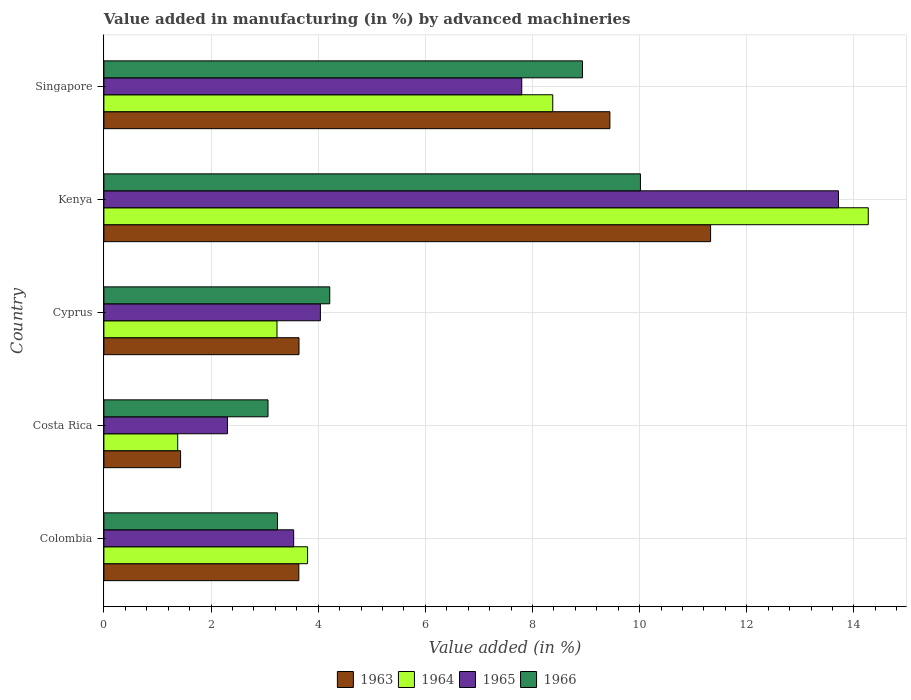How many groups of bars are there?
Keep it short and to the point. 5. Are the number of bars on each tick of the Y-axis equal?
Your answer should be very brief. Yes. What is the label of the 4th group of bars from the top?
Keep it short and to the point. Costa Rica. What is the percentage of value added in manufacturing by advanced machineries in 1964 in Colombia?
Offer a terse response. 3.8. Across all countries, what is the maximum percentage of value added in manufacturing by advanced machineries in 1964?
Your answer should be compact. 14.27. Across all countries, what is the minimum percentage of value added in manufacturing by advanced machineries in 1963?
Your answer should be compact. 1.43. In which country was the percentage of value added in manufacturing by advanced machineries in 1966 maximum?
Offer a terse response. Kenya. In which country was the percentage of value added in manufacturing by advanced machineries in 1966 minimum?
Your answer should be very brief. Costa Rica. What is the total percentage of value added in manufacturing by advanced machineries in 1965 in the graph?
Make the answer very short. 31.4. What is the difference between the percentage of value added in manufacturing by advanced machineries in 1966 in Colombia and that in Singapore?
Ensure brevity in your answer.  -5.69. What is the difference between the percentage of value added in manufacturing by advanced machineries in 1963 in Colombia and the percentage of value added in manufacturing by advanced machineries in 1966 in Kenya?
Keep it short and to the point. -6.38. What is the average percentage of value added in manufacturing by advanced machineries in 1964 per country?
Provide a short and direct response. 6.21. What is the difference between the percentage of value added in manufacturing by advanced machineries in 1965 and percentage of value added in manufacturing by advanced machineries in 1963 in Colombia?
Ensure brevity in your answer.  -0.1. What is the ratio of the percentage of value added in manufacturing by advanced machineries in 1966 in Cyprus to that in Kenya?
Your answer should be compact. 0.42. Is the difference between the percentage of value added in manufacturing by advanced machineries in 1965 in Costa Rica and Kenya greater than the difference between the percentage of value added in manufacturing by advanced machineries in 1963 in Costa Rica and Kenya?
Your answer should be very brief. No. What is the difference between the highest and the second highest percentage of value added in manufacturing by advanced machineries in 1963?
Your answer should be compact. 1.88. What is the difference between the highest and the lowest percentage of value added in manufacturing by advanced machineries in 1965?
Your answer should be compact. 11.4. In how many countries, is the percentage of value added in manufacturing by advanced machineries in 1963 greater than the average percentage of value added in manufacturing by advanced machineries in 1963 taken over all countries?
Provide a succinct answer. 2. Is the sum of the percentage of value added in manufacturing by advanced machineries in 1963 in Colombia and Cyprus greater than the maximum percentage of value added in manufacturing by advanced machineries in 1964 across all countries?
Provide a short and direct response. No. Is it the case that in every country, the sum of the percentage of value added in manufacturing by advanced machineries in 1965 and percentage of value added in manufacturing by advanced machineries in 1966 is greater than the sum of percentage of value added in manufacturing by advanced machineries in 1963 and percentage of value added in manufacturing by advanced machineries in 1964?
Give a very brief answer. No. What does the 3rd bar from the top in Colombia represents?
Your answer should be very brief. 1964. What does the 3rd bar from the bottom in Colombia represents?
Keep it short and to the point. 1965. How many countries are there in the graph?
Offer a terse response. 5. Does the graph contain any zero values?
Your answer should be compact. No. Where does the legend appear in the graph?
Offer a very short reply. Bottom center. How many legend labels are there?
Offer a terse response. 4. What is the title of the graph?
Your response must be concise. Value added in manufacturing (in %) by advanced machineries. What is the label or title of the X-axis?
Offer a very short reply. Value added (in %). What is the label or title of the Y-axis?
Keep it short and to the point. Country. What is the Value added (in %) of 1963 in Colombia?
Offer a very short reply. 3.64. What is the Value added (in %) in 1964 in Colombia?
Provide a short and direct response. 3.8. What is the Value added (in %) in 1965 in Colombia?
Offer a very short reply. 3.54. What is the Value added (in %) of 1966 in Colombia?
Your response must be concise. 3.24. What is the Value added (in %) of 1963 in Costa Rica?
Offer a very short reply. 1.43. What is the Value added (in %) in 1964 in Costa Rica?
Keep it short and to the point. 1.38. What is the Value added (in %) in 1965 in Costa Rica?
Offer a terse response. 2.31. What is the Value added (in %) of 1966 in Costa Rica?
Your answer should be very brief. 3.06. What is the Value added (in %) of 1963 in Cyprus?
Make the answer very short. 3.64. What is the Value added (in %) in 1964 in Cyprus?
Offer a terse response. 3.23. What is the Value added (in %) of 1965 in Cyprus?
Your answer should be very brief. 4.04. What is the Value added (in %) in 1966 in Cyprus?
Ensure brevity in your answer.  4.22. What is the Value added (in %) of 1963 in Kenya?
Your answer should be very brief. 11.32. What is the Value added (in %) in 1964 in Kenya?
Ensure brevity in your answer.  14.27. What is the Value added (in %) of 1965 in Kenya?
Provide a short and direct response. 13.71. What is the Value added (in %) in 1966 in Kenya?
Make the answer very short. 10.01. What is the Value added (in %) in 1963 in Singapore?
Ensure brevity in your answer.  9.44. What is the Value added (in %) in 1964 in Singapore?
Give a very brief answer. 8.38. What is the Value added (in %) in 1965 in Singapore?
Your answer should be very brief. 7.8. What is the Value added (in %) in 1966 in Singapore?
Keep it short and to the point. 8.93. Across all countries, what is the maximum Value added (in %) of 1963?
Your answer should be compact. 11.32. Across all countries, what is the maximum Value added (in %) in 1964?
Provide a short and direct response. 14.27. Across all countries, what is the maximum Value added (in %) in 1965?
Provide a succinct answer. 13.71. Across all countries, what is the maximum Value added (in %) of 1966?
Offer a terse response. 10.01. Across all countries, what is the minimum Value added (in %) of 1963?
Provide a short and direct response. 1.43. Across all countries, what is the minimum Value added (in %) in 1964?
Your response must be concise. 1.38. Across all countries, what is the minimum Value added (in %) in 1965?
Provide a succinct answer. 2.31. Across all countries, what is the minimum Value added (in %) in 1966?
Provide a short and direct response. 3.06. What is the total Value added (in %) of 1963 in the graph?
Keep it short and to the point. 29.48. What is the total Value added (in %) of 1964 in the graph?
Offer a very short reply. 31.05. What is the total Value added (in %) in 1965 in the graph?
Ensure brevity in your answer.  31.4. What is the total Value added (in %) in 1966 in the graph?
Ensure brevity in your answer.  29.47. What is the difference between the Value added (in %) of 1963 in Colombia and that in Costa Rica?
Ensure brevity in your answer.  2.21. What is the difference between the Value added (in %) in 1964 in Colombia and that in Costa Rica?
Give a very brief answer. 2.42. What is the difference between the Value added (in %) of 1965 in Colombia and that in Costa Rica?
Give a very brief answer. 1.24. What is the difference between the Value added (in %) in 1966 in Colombia and that in Costa Rica?
Your answer should be compact. 0.18. What is the difference between the Value added (in %) of 1963 in Colombia and that in Cyprus?
Ensure brevity in your answer.  -0. What is the difference between the Value added (in %) of 1964 in Colombia and that in Cyprus?
Offer a terse response. 0.57. What is the difference between the Value added (in %) of 1965 in Colombia and that in Cyprus?
Provide a succinct answer. -0.5. What is the difference between the Value added (in %) of 1966 in Colombia and that in Cyprus?
Give a very brief answer. -0.97. What is the difference between the Value added (in %) in 1963 in Colombia and that in Kenya?
Ensure brevity in your answer.  -7.69. What is the difference between the Value added (in %) in 1964 in Colombia and that in Kenya?
Make the answer very short. -10.47. What is the difference between the Value added (in %) in 1965 in Colombia and that in Kenya?
Your answer should be compact. -10.17. What is the difference between the Value added (in %) in 1966 in Colombia and that in Kenya?
Provide a succinct answer. -6.77. What is the difference between the Value added (in %) in 1963 in Colombia and that in Singapore?
Give a very brief answer. -5.81. What is the difference between the Value added (in %) of 1964 in Colombia and that in Singapore?
Offer a terse response. -4.58. What is the difference between the Value added (in %) of 1965 in Colombia and that in Singapore?
Offer a terse response. -4.26. What is the difference between the Value added (in %) of 1966 in Colombia and that in Singapore?
Offer a terse response. -5.69. What is the difference between the Value added (in %) in 1963 in Costa Rica and that in Cyprus?
Give a very brief answer. -2.21. What is the difference between the Value added (in %) in 1964 in Costa Rica and that in Cyprus?
Provide a succinct answer. -1.85. What is the difference between the Value added (in %) in 1965 in Costa Rica and that in Cyprus?
Provide a short and direct response. -1.73. What is the difference between the Value added (in %) of 1966 in Costa Rica and that in Cyprus?
Provide a succinct answer. -1.15. What is the difference between the Value added (in %) in 1963 in Costa Rica and that in Kenya?
Give a very brief answer. -9.89. What is the difference between the Value added (in %) in 1964 in Costa Rica and that in Kenya?
Provide a succinct answer. -12.89. What is the difference between the Value added (in %) in 1965 in Costa Rica and that in Kenya?
Make the answer very short. -11.4. What is the difference between the Value added (in %) of 1966 in Costa Rica and that in Kenya?
Offer a terse response. -6.95. What is the difference between the Value added (in %) in 1963 in Costa Rica and that in Singapore?
Your answer should be compact. -8.01. What is the difference between the Value added (in %) in 1964 in Costa Rica and that in Singapore?
Offer a terse response. -7. What is the difference between the Value added (in %) in 1965 in Costa Rica and that in Singapore?
Offer a terse response. -5.49. What is the difference between the Value added (in %) in 1966 in Costa Rica and that in Singapore?
Your answer should be very brief. -5.87. What is the difference between the Value added (in %) in 1963 in Cyprus and that in Kenya?
Ensure brevity in your answer.  -7.68. What is the difference between the Value added (in %) of 1964 in Cyprus and that in Kenya?
Keep it short and to the point. -11.04. What is the difference between the Value added (in %) in 1965 in Cyprus and that in Kenya?
Offer a very short reply. -9.67. What is the difference between the Value added (in %) in 1966 in Cyprus and that in Kenya?
Make the answer very short. -5.8. What is the difference between the Value added (in %) in 1963 in Cyprus and that in Singapore?
Make the answer very short. -5.8. What is the difference between the Value added (in %) of 1964 in Cyprus and that in Singapore?
Give a very brief answer. -5.15. What is the difference between the Value added (in %) in 1965 in Cyprus and that in Singapore?
Give a very brief answer. -3.76. What is the difference between the Value added (in %) of 1966 in Cyprus and that in Singapore?
Keep it short and to the point. -4.72. What is the difference between the Value added (in %) of 1963 in Kenya and that in Singapore?
Give a very brief answer. 1.88. What is the difference between the Value added (in %) of 1964 in Kenya and that in Singapore?
Offer a very short reply. 5.89. What is the difference between the Value added (in %) in 1965 in Kenya and that in Singapore?
Your answer should be compact. 5.91. What is the difference between the Value added (in %) in 1966 in Kenya and that in Singapore?
Your answer should be compact. 1.08. What is the difference between the Value added (in %) in 1963 in Colombia and the Value added (in %) in 1964 in Costa Rica?
Your answer should be compact. 2.26. What is the difference between the Value added (in %) of 1963 in Colombia and the Value added (in %) of 1965 in Costa Rica?
Give a very brief answer. 1.33. What is the difference between the Value added (in %) in 1963 in Colombia and the Value added (in %) in 1966 in Costa Rica?
Your response must be concise. 0.57. What is the difference between the Value added (in %) in 1964 in Colombia and the Value added (in %) in 1965 in Costa Rica?
Offer a terse response. 1.49. What is the difference between the Value added (in %) of 1964 in Colombia and the Value added (in %) of 1966 in Costa Rica?
Your response must be concise. 0.74. What is the difference between the Value added (in %) in 1965 in Colombia and the Value added (in %) in 1966 in Costa Rica?
Your answer should be compact. 0.48. What is the difference between the Value added (in %) in 1963 in Colombia and the Value added (in %) in 1964 in Cyprus?
Your answer should be very brief. 0.41. What is the difference between the Value added (in %) in 1963 in Colombia and the Value added (in %) in 1965 in Cyprus?
Your answer should be very brief. -0.4. What is the difference between the Value added (in %) of 1963 in Colombia and the Value added (in %) of 1966 in Cyprus?
Offer a very short reply. -0.58. What is the difference between the Value added (in %) of 1964 in Colombia and the Value added (in %) of 1965 in Cyprus?
Ensure brevity in your answer.  -0.24. What is the difference between the Value added (in %) of 1964 in Colombia and the Value added (in %) of 1966 in Cyprus?
Offer a very short reply. -0.41. What is the difference between the Value added (in %) of 1965 in Colombia and the Value added (in %) of 1966 in Cyprus?
Ensure brevity in your answer.  -0.67. What is the difference between the Value added (in %) of 1963 in Colombia and the Value added (in %) of 1964 in Kenya?
Offer a very short reply. -10.63. What is the difference between the Value added (in %) of 1963 in Colombia and the Value added (in %) of 1965 in Kenya?
Your answer should be compact. -10.07. What is the difference between the Value added (in %) in 1963 in Colombia and the Value added (in %) in 1966 in Kenya?
Offer a very short reply. -6.38. What is the difference between the Value added (in %) in 1964 in Colombia and the Value added (in %) in 1965 in Kenya?
Offer a terse response. -9.91. What is the difference between the Value added (in %) of 1964 in Colombia and the Value added (in %) of 1966 in Kenya?
Your answer should be compact. -6.21. What is the difference between the Value added (in %) of 1965 in Colombia and the Value added (in %) of 1966 in Kenya?
Make the answer very short. -6.47. What is the difference between the Value added (in %) of 1963 in Colombia and the Value added (in %) of 1964 in Singapore?
Your answer should be very brief. -4.74. What is the difference between the Value added (in %) in 1963 in Colombia and the Value added (in %) in 1965 in Singapore?
Give a very brief answer. -4.16. What is the difference between the Value added (in %) of 1963 in Colombia and the Value added (in %) of 1966 in Singapore?
Your answer should be compact. -5.29. What is the difference between the Value added (in %) of 1964 in Colombia and the Value added (in %) of 1965 in Singapore?
Keep it short and to the point. -4. What is the difference between the Value added (in %) of 1964 in Colombia and the Value added (in %) of 1966 in Singapore?
Make the answer very short. -5.13. What is the difference between the Value added (in %) of 1965 in Colombia and the Value added (in %) of 1966 in Singapore?
Give a very brief answer. -5.39. What is the difference between the Value added (in %) of 1963 in Costa Rica and the Value added (in %) of 1964 in Cyprus?
Offer a very short reply. -1.8. What is the difference between the Value added (in %) in 1963 in Costa Rica and the Value added (in %) in 1965 in Cyprus?
Your response must be concise. -2.61. What is the difference between the Value added (in %) of 1963 in Costa Rica and the Value added (in %) of 1966 in Cyprus?
Give a very brief answer. -2.78. What is the difference between the Value added (in %) in 1964 in Costa Rica and the Value added (in %) in 1965 in Cyprus?
Offer a terse response. -2.66. What is the difference between the Value added (in %) in 1964 in Costa Rica and the Value added (in %) in 1966 in Cyprus?
Make the answer very short. -2.84. What is the difference between the Value added (in %) in 1965 in Costa Rica and the Value added (in %) in 1966 in Cyprus?
Provide a short and direct response. -1.91. What is the difference between the Value added (in %) of 1963 in Costa Rica and the Value added (in %) of 1964 in Kenya?
Offer a terse response. -12.84. What is the difference between the Value added (in %) in 1963 in Costa Rica and the Value added (in %) in 1965 in Kenya?
Give a very brief answer. -12.28. What is the difference between the Value added (in %) in 1963 in Costa Rica and the Value added (in %) in 1966 in Kenya?
Your answer should be compact. -8.58. What is the difference between the Value added (in %) in 1964 in Costa Rica and the Value added (in %) in 1965 in Kenya?
Your answer should be compact. -12.33. What is the difference between the Value added (in %) of 1964 in Costa Rica and the Value added (in %) of 1966 in Kenya?
Keep it short and to the point. -8.64. What is the difference between the Value added (in %) in 1965 in Costa Rica and the Value added (in %) in 1966 in Kenya?
Provide a succinct answer. -7.71. What is the difference between the Value added (in %) of 1963 in Costa Rica and the Value added (in %) of 1964 in Singapore?
Give a very brief answer. -6.95. What is the difference between the Value added (in %) of 1963 in Costa Rica and the Value added (in %) of 1965 in Singapore?
Make the answer very short. -6.37. What is the difference between the Value added (in %) in 1963 in Costa Rica and the Value added (in %) in 1966 in Singapore?
Provide a succinct answer. -7.5. What is the difference between the Value added (in %) in 1964 in Costa Rica and the Value added (in %) in 1965 in Singapore?
Provide a succinct answer. -6.42. What is the difference between the Value added (in %) in 1964 in Costa Rica and the Value added (in %) in 1966 in Singapore?
Provide a succinct answer. -7.55. What is the difference between the Value added (in %) in 1965 in Costa Rica and the Value added (in %) in 1966 in Singapore?
Give a very brief answer. -6.63. What is the difference between the Value added (in %) in 1963 in Cyprus and the Value added (in %) in 1964 in Kenya?
Keep it short and to the point. -10.63. What is the difference between the Value added (in %) in 1963 in Cyprus and the Value added (in %) in 1965 in Kenya?
Provide a succinct answer. -10.07. What is the difference between the Value added (in %) of 1963 in Cyprus and the Value added (in %) of 1966 in Kenya?
Provide a succinct answer. -6.37. What is the difference between the Value added (in %) in 1964 in Cyprus and the Value added (in %) in 1965 in Kenya?
Give a very brief answer. -10.48. What is the difference between the Value added (in %) of 1964 in Cyprus and the Value added (in %) of 1966 in Kenya?
Offer a very short reply. -6.78. What is the difference between the Value added (in %) of 1965 in Cyprus and the Value added (in %) of 1966 in Kenya?
Ensure brevity in your answer.  -5.97. What is the difference between the Value added (in %) in 1963 in Cyprus and the Value added (in %) in 1964 in Singapore?
Provide a succinct answer. -4.74. What is the difference between the Value added (in %) of 1963 in Cyprus and the Value added (in %) of 1965 in Singapore?
Give a very brief answer. -4.16. What is the difference between the Value added (in %) in 1963 in Cyprus and the Value added (in %) in 1966 in Singapore?
Your answer should be very brief. -5.29. What is the difference between the Value added (in %) of 1964 in Cyprus and the Value added (in %) of 1965 in Singapore?
Provide a succinct answer. -4.57. What is the difference between the Value added (in %) in 1964 in Cyprus and the Value added (in %) in 1966 in Singapore?
Your response must be concise. -5.7. What is the difference between the Value added (in %) of 1965 in Cyprus and the Value added (in %) of 1966 in Singapore?
Your answer should be compact. -4.89. What is the difference between the Value added (in %) in 1963 in Kenya and the Value added (in %) in 1964 in Singapore?
Offer a very short reply. 2.95. What is the difference between the Value added (in %) in 1963 in Kenya and the Value added (in %) in 1965 in Singapore?
Your answer should be compact. 3.52. What is the difference between the Value added (in %) of 1963 in Kenya and the Value added (in %) of 1966 in Singapore?
Give a very brief answer. 2.39. What is the difference between the Value added (in %) of 1964 in Kenya and the Value added (in %) of 1965 in Singapore?
Give a very brief answer. 6.47. What is the difference between the Value added (in %) in 1964 in Kenya and the Value added (in %) in 1966 in Singapore?
Your answer should be compact. 5.33. What is the difference between the Value added (in %) in 1965 in Kenya and the Value added (in %) in 1966 in Singapore?
Provide a short and direct response. 4.78. What is the average Value added (in %) in 1963 per country?
Your answer should be very brief. 5.9. What is the average Value added (in %) in 1964 per country?
Your answer should be compact. 6.21. What is the average Value added (in %) in 1965 per country?
Offer a very short reply. 6.28. What is the average Value added (in %) of 1966 per country?
Your answer should be very brief. 5.89. What is the difference between the Value added (in %) in 1963 and Value added (in %) in 1964 in Colombia?
Make the answer very short. -0.16. What is the difference between the Value added (in %) of 1963 and Value added (in %) of 1965 in Colombia?
Offer a very short reply. 0.1. What is the difference between the Value added (in %) in 1963 and Value added (in %) in 1966 in Colombia?
Keep it short and to the point. 0.4. What is the difference between the Value added (in %) in 1964 and Value added (in %) in 1965 in Colombia?
Your response must be concise. 0.26. What is the difference between the Value added (in %) of 1964 and Value added (in %) of 1966 in Colombia?
Give a very brief answer. 0.56. What is the difference between the Value added (in %) in 1965 and Value added (in %) in 1966 in Colombia?
Provide a succinct answer. 0.3. What is the difference between the Value added (in %) in 1963 and Value added (in %) in 1964 in Costa Rica?
Your answer should be compact. 0.05. What is the difference between the Value added (in %) of 1963 and Value added (in %) of 1965 in Costa Rica?
Give a very brief answer. -0.88. What is the difference between the Value added (in %) in 1963 and Value added (in %) in 1966 in Costa Rica?
Offer a terse response. -1.63. What is the difference between the Value added (in %) of 1964 and Value added (in %) of 1965 in Costa Rica?
Your answer should be very brief. -0.93. What is the difference between the Value added (in %) of 1964 and Value added (in %) of 1966 in Costa Rica?
Your answer should be very brief. -1.69. What is the difference between the Value added (in %) in 1965 and Value added (in %) in 1966 in Costa Rica?
Make the answer very short. -0.76. What is the difference between the Value added (in %) in 1963 and Value added (in %) in 1964 in Cyprus?
Your answer should be very brief. 0.41. What is the difference between the Value added (in %) in 1963 and Value added (in %) in 1965 in Cyprus?
Ensure brevity in your answer.  -0.4. What is the difference between the Value added (in %) of 1963 and Value added (in %) of 1966 in Cyprus?
Keep it short and to the point. -0.57. What is the difference between the Value added (in %) of 1964 and Value added (in %) of 1965 in Cyprus?
Keep it short and to the point. -0.81. What is the difference between the Value added (in %) in 1964 and Value added (in %) in 1966 in Cyprus?
Offer a terse response. -0.98. What is the difference between the Value added (in %) of 1965 and Value added (in %) of 1966 in Cyprus?
Provide a short and direct response. -0.17. What is the difference between the Value added (in %) of 1963 and Value added (in %) of 1964 in Kenya?
Keep it short and to the point. -2.94. What is the difference between the Value added (in %) of 1963 and Value added (in %) of 1965 in Kenya?
Make the answer very short. -2.39. What is the difference between the Value added (in %) of 1963 and Value added (in %) of 1966 in Kenya?
Offer a very short reply. 1.31. What is the difference between the Value added (in %) in 1964 and Value added (in %) in 1965 in Kenya?
Keep it short and to the point. 0.56. What is the difference between the Value added (in %) in 1964 and Value added (in %) in 1966 in Kenya?
Offer a terse response. 4.25. What is the difference between the Value added (in %) of 1965 and Value added (in %) of 1966 in Kenya?
Give a very brief answer. 3.7. What is the difference between the Value added (in %) of 1963 and Value added (in %) of 1964 in Singapore?
Keep it short and to the point. 1.07. What is the difference between the Value added (in %) of 1963 and Value added (in %) of 1965 in Singapore?
Give a very brief answer. 1.64. What is the difference between the Value added (in %) of 1963 and Value added (in %) of 1966 in Singapore?
Give a very brief answer. 0.51. What is the difference between the Value added (in %) of 1964 and Value added (in %) of 1965 in Singapore?
Offer a very short reply. 0.58. What is the difference between the Value added (in %) of 1964 and Value added (in %) of 1966 in Singapore?
Your answer should be compact. -0.55. What is the difference between the Value added (in %) in 1965 and Value added (in %) in 1966 in Singapore?
Your answer should be very brief. -1.13. What is the ratio of the Value added (in %) in 1963 in Colombia to that in Costa Rica?
Offer a terse response. 2.54. What is the ratio of the Value added (in %) of 1964 in Colombia to that in Costa Rica?
Provide a short and direct response. 2.76. What is the ratio of the Value added (in %) in 1965 in Colombia to that in Costa Rica?
Ensure brevity in your answer.  1.54. What is the ratio of the Value added (in %) of 1966 in Colombia to that in Costa Rica?
Offer a terse response. 1.06. What is the ratio of the Value added (in %) in 1963 in Colombia to that in Cyprus?
Provide a succinct answer. 1. What is the ratio of the Value added (in %) of 1964 in Colombia to that in Cyprus?
Ensure brevity in your answer.  1.18. What is the ratio of the Value added (in %) of 1965 in Colombia to that in Cyprus?
Keep it short and to the point. 0.88. What is the ratio of the Value added (in %) in 1966 in Colombia to that in Cyprus?
Your answer should be very brief. 0.77. What is the ratio of the Value added (in %) in 1963 in Colombia to that in Kenya?
Your answer should be very brief. 0.32. What is the ratio of the Value added (in %) of 1964 in Colombia to that in Kenya?
Provide a short and direct response. 0.27. What is the ratio of the Value added (in %) of 1965 in Colombia to that in Kenya?
Provide a succinct answer. 0.26. What is the ratio of the Value added (in %) of 1966 in Colombia to that in Kenya?
Offer a very short reply. 0.32. What is the ratio of the Value added (in %) in 1963 in Colombia to that in Singapore?
Your answer should be compact. 0.39. What is the ratio of the Value added (in %) of 1964 in Colombia to that in Singapore?
Offer a terse response. 0.45. What is the ratio of the Value added (in %) of 1965 in Colombia to that in Singapore?
Your response must be concise. 0.45. What is the ratio of the Value added (in %) in 1966 in Colombia to that in Singapore?
Your response must be concise. 0.36. What is the ratio of the Value added (in %) of 1963 in Costa Rica to that in Cyprus?
Keep it short and to the point. 0.39. What is the ratio of the Value added (in %) of 1964 in Costa Rica to that in Cyprus?
Your response must be concise. 0.43. What is the ratio of the Value added (in %) of 1965 in Costa Rica to that in Cyprus?
Offer a terse response. 0.57. What is the ratio of the Value added (in %) of 1966 in Costa Rica to that in Cyprus?
Keep it short and to the point. 0.73. What is the ratio of the Value added (in %) of 1963 in Costa Rica to that in Kenya?
Offer a very short reply. 0.13. What is the ratio of the Value added (in %) of 1964 in Costa Rica to that in Kenya?
Ensure brevity in your answer.  0.1. What is the ratio of the Value added (in %) of 1965 in Costa Rica to that in Kenya?
Provide a succinct answer. 0.17. What is the ratio of the Value added (in %) of 1966 in Costa Rica to that in Kenya?
Keep it short and to the point. 0.31. What is the ratio of the Value added (in %) in 1963 in Costa Rica to that in Singapore?
Offer a very short reply. 0.15. What is the ratio of the Value added (in %) of 1964 in Costa Rica to that in Singapore?
Provide a short and direct response. 0.16. What is the ratio of the Value added (in %) of 1965 in Costa Rica to that in Singapore?
Your response must be concise. 0.3. What is the ratio of the Value added (in %) of 1966 in Costa Rica to that in Singapore?
Keep it short and to the point. 0.34. What is the ratio of the Value added (in %) in 1963 in Cyprus to that in Kenya?
Your answer should be compact. 0.32. What is the ratio of the Value added (in %) in 1964 in Cyprus to that in Kenya?
Ensure brevity in your answer.  0.23. What is the ratio of the Value added (in %) of 1965 in Cyprus to that in Kenya?
Give a very brief answer. 0.29. What is the ratio of the Value added (in %) in 1966 in Cyprus to that in Kenya?
Keep it short and to the point. 0.42. What is the ratio of the Value added (in %) of 1963 in Cyprus to that in Singapore?
Provide a succinct answer. 0.39. What is the ratio of the Value added (in %) of 1964 in Cyprus to that in Singapore?
Provide a succinct answer. 0.39. What is the ratio of the Value added (in %) in 1965 in Cyprus to that in Singapore?
Ensure brevity in your answer.  0.52. What is the ratio of the Value added (in %) of 1966 in Cyprus to that in Singapore?
Offer a terse response. 0.47. What is the ratio of the Value added (in %) of 1963 in Kenya to that in Singapore?
Your answer should be very brief. 1.2. What is the ratio of the Value added (in %) of 1964 in Kenya to that in Singapore?
Your response must be concise. 1.7. What is the ratio of the Value added (in %) in 1965 in Kenya to that in Singapore?
Offer a very short reply. 1.76. What is the ratio of the Value added (in %) of 1966 in Kenya to that in Singapore?
Your answer should be compact. 1.12. What is the difference between the highest and the second highest Value added (in %) in 1963?
Keep it short and to the point. 1.88. What is the difference between the highest and the second highest Value added (in %) of 1964?
Your response must be concise. 5.89. What is the difference between the highest and the second highest Value added (in %) in 1965?
Your response must be concise. 5.91. What is the difference between the highest and the second highest Value added (in %) in 1966?
Your answer should be very brief. 1.08. What is the difference between the highest and the lowest Value added (in %) in 1963?
Make the answer very short. 9.89. What is the difference between the highest and the lowest Value added (in %) in 1964?
Offer a very short reply. 12.89. What is the difference between the highest and the lowest Value added (in %) in 1965?
Offer a terse response. 11.4. What is the difference between the highest and the lowest Value added (in %) in 1966?
Your answer should be compact. 6.95. 